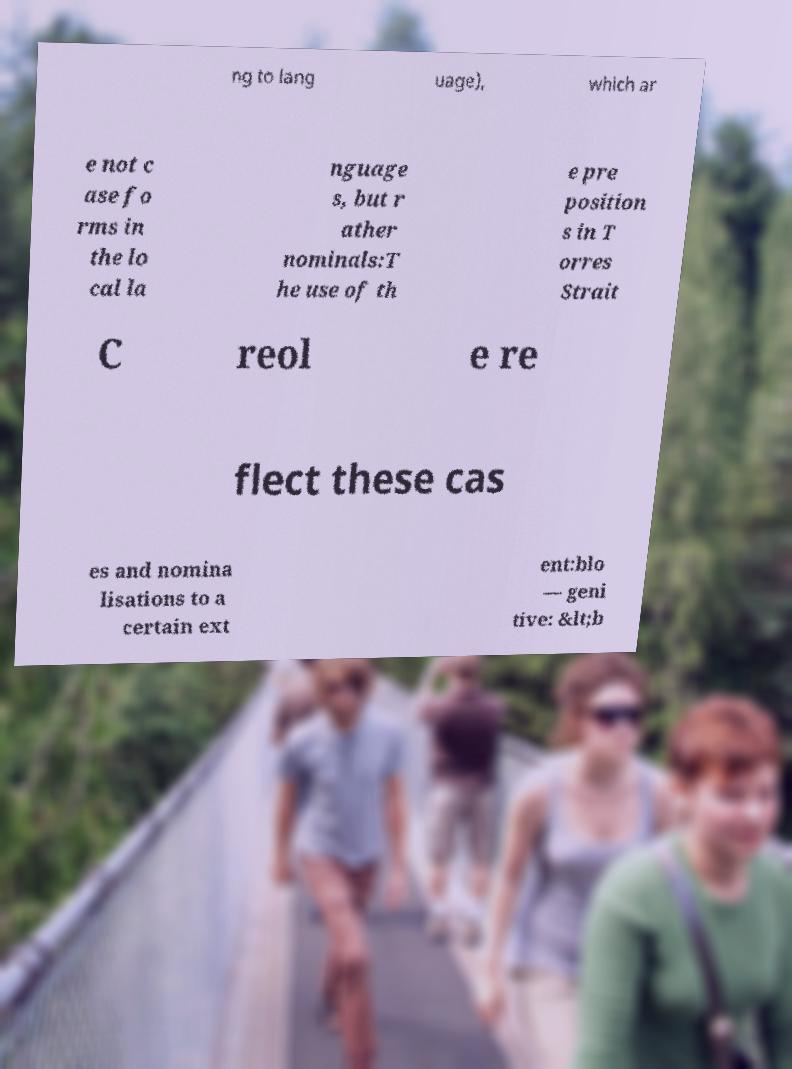Can you read and provide the text displayed in the image?This photo seems to have some interesting text. Can you extract and type it out for me? ng to lang uage), which ar e not c ase fo rms in the lo cal la nguage s, but r ather nominals:T he use of th e pre position s in T orres Strait C reol e re flect these cas es and nomina lisations to a certain ext ent:blo — geni tive: &lt;b 